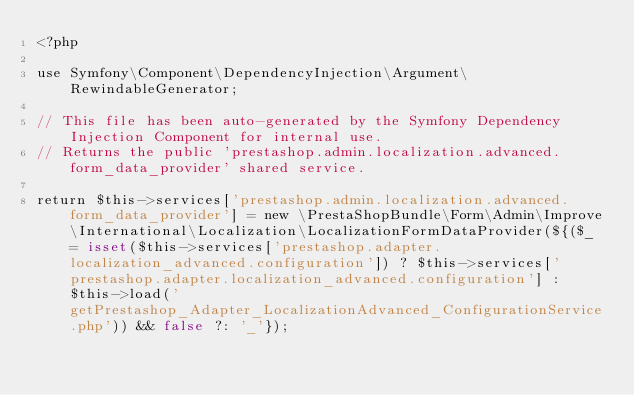<code> <loc_0><loc_0><loc_500><loc_500><_PHP_><?php

use Symfony\Component\DependencyInjection\Argument\RewindableGenerator;

// This file has been auto-generated by the Symfony Dependency Injection Component for internal use.
// Returns the public 'prestashop.admin.localization.advanced.form_data_provider' shared service.

return $this->services['prestashop.admin.localization.advanced.form_data_provider'] = new \PrestaShopBundle\Form\Admin\Improve\International\Localization\LocalizationFormDataProvider(${($_ = isset($this->services['prestashop.adapter.localization_advanced.configuration']) ? $this->services['prestashop.adapter.localization_advanced.configuration'] : $this->load('getPrestashop_Adapter_LocalizationAdvanced_ConfigurationService.php')) && false ?: '_'});
</code> 